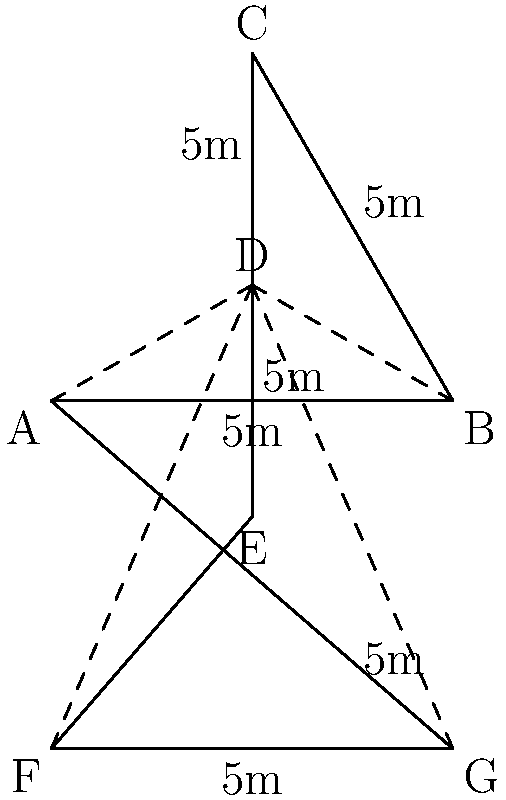For an upcoming stunt scene, you need to design a star-shaped stage. The stage is formed by a regular hexagon with an equilateral triangle on top, as shown in the diagram. If each side of the shape measures 5 meters, what is the perimeter of the entire stage? To find the perimeter of the star-shaped stage, we need to count the number of sides and multiply by the length of each side:

1. Count the sides:
   - The hexagon has 6 sides
   - The triangle adds 2 more sides (the base is already counted in the hexagon)
   - Total number of sides = 6 + 2 = 8 sides

2. Calculate the perimeter:
   - Each side measures 5 meters
   - Perimeter = Number of sides × Length of each side
   - Perimeter = 8 × 5 meters
   - Perimeter = 40 meters

Therefore, the perimeter of the star-shaped stage is 40 meters.
Answer: 40 meters 